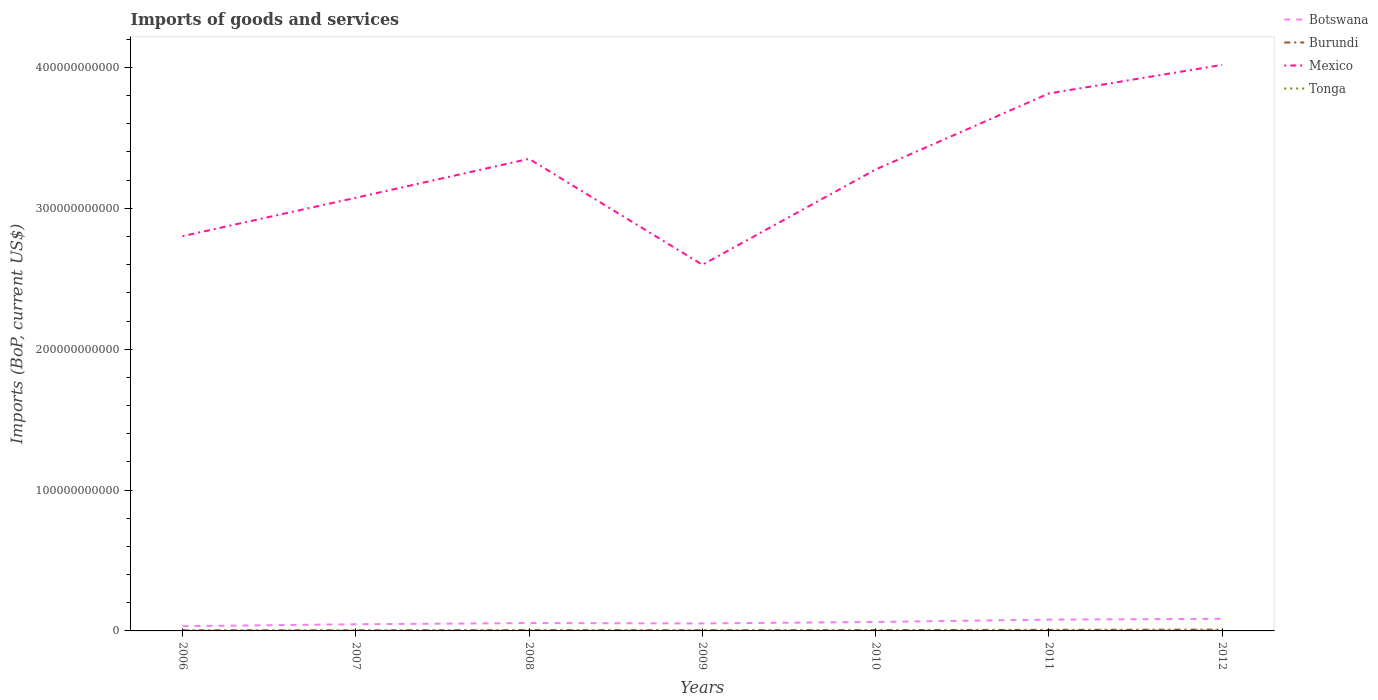Does the line corresponding to Mexico intersect with the line corresponding to Burundi?
Keep it short and to the point. No. Across all years, what is the maximum amount spent on imports in Tonga?
Keep it short and to the point. 1.70e+08. In which year was the amount spent on imports in Botswana maximum?
Your response must be concise. 2006. What is the total amount spent on imports in Botswana in the graph?
Your response must be concise. -1.62e+09. What is the difference between the highest and the second highest amount spent on imports in Burundi?
Provide a short and direct response. 4.86e+08. What is the difference between the highest and the lowest amount spent on imports in Burundi?
Your response must be concise. 2. Is the amount spent on imports in Tonga strictly greater than the amount spent on imports in Burundi over the years?
Ensure brevity in your answer.  Yes. How many years are there in the graph?
Offer a terse response. 7. What is the difference between two consecutive major ticks on the Y-axis?
Your response must be concise. 1.00e+11. Does the graph contain grids?
Keep it short and to the point. No. How are the legend labels stacked?
Make the answer very short. Vertical. What is the title of the graph?
Your answer should be compact. Imports of goods and services. What is the label or title of the X-axis?
Make the answer very short. Years. What is the label or title of the Y-axis?
Offer a terse response. Imports (BoP, current US$). What is the Imports (BoP, current US$) in Botswana in 2006?
Offer a very short reply. 3.35e+09. What is the Imports (BoP, current US$) in Burundi in 2006?
Your response must be concise. 4.47e+08. What is the Imports (BoP, current US$) in Mexico in 2006?
Make the answer very short. 2.80e+11. What is the Imports (BoP, current US$) of Tonga in 2006?
Offer a terse response. 1.70e+08. What is the Imports (BoP, current US$) of Botswana in 2007?
Your answer should be very brief. 4.73e+09. What is the Imports (BoP, current US$) in Burundi in 2007?
Your response must be concise. 4.36e+08. What is the Imports (BoP, current US$) in Mexico in 2007?
Your answer should be compact. 3.08e+11. What is the Imports (BoP, current US$) of Tonga in 2007?
Your response must be concise. 1.99e+08. What is the Imports (BoP, current US$) in Botswana in 2008?
Your response must be concise. 5.59e+09. What is the Imports (BoP, current US$) of Burundi in 2008?
Provide a short and direct response. 5.94e+08. What is the Imports (BoP, current US$) in Mexico in 2008?
Provide a succinct answer. 3.35e+11. What is the Imports (BoP, current US$) in Tonga in 2008?
Provide a short and direct response. 2.47e+08. What is the Imports (BoP, current US$) of Botswana in 2009?
Offer a terse response. 5.33e+09. What is the Imports (BoP, current US$) in Burundi in 2009?
Make the answer very short. 5.20e+08. What is the Imports (BoP, current US$) of Mexico in 2009?
Your answer should be very brief. 2.60e+11. What is the Imports (BoP, current US$) in Tonga in 2009?
Your response must be concise. 2.39e+08. What is the Imports (BoP, current US$) of Botswana in 2010?
Keep it short and to the point. 6.36e+09. What is the Imports (BoP, current US$) in Burundi in 2010?
Ensure brevity in your answer.  6.07e+08. What is the Imports (BoP, current US$) of Mexico in 2010?
Your answer should be compact. 3.28e+11. What is the Imports (BoP, current US$) of Tonga in 2010?
Ensure brevity in your answer.  2.27e+08. What is the Imports (BoP, current US$) in Botswana in 2011?
Ensure brevity in your answer.  8.03e+09. What is the Imports (BoP, current US$) of Burundi in 2011?
Keep it short and to the point. 7.65e+08. What is the Imports (BoP, current US$) of Mexico in 2011?
Keep it short and to the point. 3.82e+11. What is the Imports (BoP, current US$) in Tonga in 2011?
Your answer should be compact. 2.78e+08. What is the Imports (BoP, current US$) in Botswana in 2012?
Give a very brief answer. 8.59e+09. What is the Imports (BoP, current US$) in Burundi in 2012?
Your response must be concise. 9.23e+08. What is the Imports (BoP, current US$) of Mexico in 2012?
Offer a terse response. 4.02e+11. What is the Imports (BoP, current US$) in Tonga in 2012?
Give a very brief answer. 2.71e+08. Across all years, what is the maximum Imports (BoP, current US$) in Botswana?
Ensure brevity in your answer.  8.59e+09. Across all years, what is the maximum Imports (BoP, current US$) in Burundi?
Offer a very short reply. 9.23e+08. Across all years, what is the maximum Imports (BoP, current US$) in Mexico?
Your answer should be compact. 4.02e+11. Across all years, what is the maximum Imports (BoP, current US$) of Tonga?
Keep it short and to the point. 2.78e+08. Across all years, what is the minimum Imports (BoP, current US$) in Botswana?
Offer a very short reply. 3.35e+09. Across all years, what is the minimum Imports (BoP, current US$) of Burundi?
Ensure brevity in your answer.  4.36e+08. Across all years, what is the minimum Imports (BoP, current US$) of Mexico?
Offer a terse response. 2.60e+11. Across all years, what is the minimum Imports (BoP, current US$) of Tonga?
Make the answer very short. 1.70e+08. What is the total Imports (BoP, current US$) of Botswana in the graph?
Make the answer very short. 4.20e+1. What is the total Imports (BoP, current US$) of Burundi in the graph?
Offer a terse response. 4.29e+09. What is the total Imports (BoP, current US$) of Mexico in the graph?
Ensure brevity in your answer.  2.29e+12. What is the total Imports (BoP, current US$) in Tonga in the graph?
Provide a short and direct response. 1.63e+09. What is the difference between the Imports (BoP, current US$) of Botswana in 2006 and that in 2007?
Offer a very short reply. -1.38e+09. What is the difference between the Imports (BoP, current US$) in Burundi in 2006 and that in 2007?
Your answer should be compact. 1.07e+07. What is the difference between the Imports (BoP, current US$) of Mexico in 2006 and that in 2007?
Provide a succinct answer. -2.72e+1. What is the difference between the Imports (BoP, current US$) of Tonga in 2006 and that in 2007?
Provide a succinct answer. -2.89e+07. What is the difference between the Imports (BoP, current US$) in Botswana in 2006 and that in 2008?
Your response must be concise. -2.23e+09. What is the difference between the Imports (BoP, current US$) of Burundi in 2006 and that in 2008?
Offer a terse response. -1.47e+08. What is the difference between the Imports (BoP, current US$) of Mexico in 2006 and that in 2008?
Provide a short and direct response. -5.49e+1. What is the difference between the Imports (BoP, current US$) of Tonga in 2006 and that in 2008?
Provide a succinct answer. -7.70e+07. What is the difference between the Imports (BoP, current US$) in Botswana in 2006 and that in 2009?
Keep it short and to the point. -1.97e+09. What is the difference between the Imports (BoP, current US$) in Burundi in 2006 and that in 2009?
Give a very brief answer. -7.27e+07. What is the difference between the Imports (BoP, current US$) of Mexico in 2006 and that in 2009?
Your response must be concise. 2.03e+1. What is the difference between the Imports (BoP, current US$) in Tonga in 2006 and that in 2009?
Ensure brevity in your answer.  -6.88e+07. What is the difference between the Imports (BoP, current US$) of Botswana in 2006 and that in 2010?
Make the answer very short. -3.01e+09. What is the difference between the Imports (BoP, current US$) in Burundi in 2006 and that in 2010?
Your response must be concise. -1.60e+08. What is the difference between the Imports (BoP, current US$) in Mexico in 2006 and that in 2010?
Your answer should be compact. -4.73e+1. What is the difference between the Imports (BoP, current US$) of Tonga in 2006 and that in 2010?
Make the answer very short. -5.69e+07. What is the difference between the Imports (BoP, current US$) of Botswana in 2006 and that in 2011?
Offer a very short reply. -4.68e+09. What is the difference between the Imports (BoP, current US$) of Burundi in 2006 and that in 2011?
Ensure brevity in your answer.  -3.18e+08. What is the difference between the Imports (BoP, current US$) in Mexico in 2006 and that in 2011?
Give a very brief answer. -1.01e+11. What is the difference between the Imports (BoP, current US$) in Tonga in 2006 and that in 2011?
Ensure brevity in your answer.  -1.07e+08. What is the difference between the Imports (BoP, current US$) in Botswana in 2006 and that in 2012?
Your answer should be very brief. -5.24e+09. What is the difference between the Imports (BoP, current US$) of Burundi in 2006 and that in 2012?
Make the answer very short. -4.76e+08. What is the difference between the Imports (BoP, current US$) of Mexico in 2006 and that in 2012?
Your answer should be compact. -1.22e+11. What is the difference between the Imports (BoP, current US$) in Tonga in 2006 and that in 2012?
Offer a very short reply. -1.00e+08. What is the difference between the Imports (BoP, current US$) of Botswana in 2007 and that in 2008?
Offer a very short reply. -8.52e+08. What is the difference between the Imports (BoP, current US$) in Burundi in 2007 and that in 2008?
Make the answer very short. -1.58e+08. What is the difference between the Imports (BoP, current US$) of Mexico in 2007 and that in 2008?
Your answer should be very brief. -2.76e+1. What is the difference between the Imports (BoP, current US$) in Tonga in 2007 and that in 2008?
Provide a short and direct response. -4.81e+07. What is the difference between the Imports (BoP, current US$) in Botswana in 2007 and that in 2009?
Your response must be concise. -5.93e+08. What is the difference between the Imports (BoP, current US$) of Burundi in 2007 and that in 2009?
Your answer should be very brief. -8.34e+07. What is the difference between the Imports (BoP, current US$) of Mexico in 2007 and that in 2009?
Keep it short and to the point. 4.76e+1. What is the difference between the Imports (BoP, current US$) in Tonga in 2007 and that in 2009?
Provide a short and direct response. -3.99e+07. What is the difference between the Imports (BoP, current US$) of Botswana in 2007 and that in 2010?
Offer a very short reply. -1.62e+09. What is the difference between the Imports (BoP, current US$) of Burundi in 2007 and that in 2010?
Your answer should be very brief. -1.70e+08. What is the difference between the Imports (BoP, current US$) in Mexico in 2007 and that in 2010?
Give a very brief answer. -2.01e+1. What is the difference between the Imports (BoP, current US$) of Tonga in 2007 and that in 2010?
Your answer should be compact. -2.79e+07. What is the difference between the Imports (BoP, current US$) in Botswana in 2007 and that in 2011?
Your response must be concise. -3.30e+09. What is the difference between the Imports (BoP, current US$) of Burundi in 2007 and that in 2011?
Your answer should be compact. -3.29e+08. What is the difference between the Imports (BoP, current US$) of Mexico in 2007 and that in 2011?
Provide a short and direct response. -7.41e+1. What is the difference between the Imports (BoP, current US$) in Tonga in 2007 and that in 2011?
Provide a short and direct response. -7.82e+07. What is the difference between the Imports (BoP, current US$) in Botswana in 2007 and that in 2012?
Offer a terse response. -3.85e+09. What is the difference between the Imports (BoP, current US$) of Burundi in 2007 and that in 2012?
Your answer should be compact. -4.86e+08. What is the difference between the Imports (BoP, current US$) in Mexico in 2007 and that in 2012?
Offer a very short reply. -9.44e+1. What is the difference between the Imports (BoP, current US$) in Tonga in 2007 and that in 2012?
Provide a short and direct response. -7.12e+07. What is the difference between the Imports (BoP, current US$) in Botswana in 2008 and that in 2009?
Provide a succinct answer. 2.60e+08. What is the difference between the Imports (BoP, current US$) of Burundi in 2008 and that in 2009?
Ensure brevity in your answer.  7.46e+07. What is the difference between the Imports (BoP, current US$) of Mexico in 2008 and that in 2009?
Your answer should be compact. 7.52e+1. What is the difference between the Imports (BoP, current US$) of Tonga in 2008 and that in 2009?
Give a very brief answer. 8.26e+06. What is the difference between the Imports (BoP, current US$) in Botswana in 2008 and that in 2010?
Make the answer very short. -7.70e+08. What is the difference between the Imports (BoP, current US$) of Burundi in 2008 and that in 2010?
Your answer should be compact. -1.25e+07. What is the difference between the Imports (BoP, current US$) in Mexico in 2008 and that in 2010?
Offer a very short reply. 7.56e+09. What is the difference between the Imports (BoP, current US$) in Tonga in 2008 and that in 2010?
Give a very brief answer. 2.02e+07. What is the difference between the Imports (BoP, current US$) in Botswana in 2008 and that in 2011?
Provide a succinct answer. -2.44e+09. What is the difference between the Imports (BoP, current US$) in Burundi in 2008 and that in 2011?
Offer a very short reply. -1.71e+08. What is the difference between the Imports (BoP, current US$) in Mexico in 2008 and that in 2011?
Give a very brief answer. -4.64e+1. What is the difference between the Imports (BoP, current US$) in Tonga in 2008 and that in 2011?
Offer a very short reply. -3.01e+07. What is the difference between the Imports (BoP, current US$) of Botswana in 2008 and that in 2012?
Keep it short and to the point. -3.00e+09. What is the difference between the Imports (BoP, current US$) of Burundi in 2008 and that in 2012?
Provide a succinct answer. -3.28e+08. What is the difference between the Imports (BoP, current US$) of Mexico in 2008 and that in 2012?
Give a very brief answer. -6.67e+1. What is the difference between the Imports (BoP, current US$) of Tonga in 2008 and that in 2012?
Your answer should be very brief. -2.31e+07. What is the difference between the Imports (BoP, current US$) of Botswana in 2009 and that in 2010?
Offer a very short reply. -1.03e+09. What is the difference between the Imports (BoP, current US$) in Burundi in 2009 and that in 2010?
Provide a succinct answer. -8.71e+07. What is the difference between the Imports (BoP, current US$) in Mexico in 2009 and that in 2010?
Your answer should be very brief. -6.77e+1. What is the difference between the Imports (BoP, current US$) in Tonga in 2009 and that in 2010?
Your response must be concise. 1.19e+07. What is the difference between the Imports (BoP, current US$) of Botswana in 2009 and that in 2011?
Give a very brief answer. -2.70e+09. What is the difference between the Imports (BoP, current US$) in Burundi in 2009 and that in 2011?
Provide a succinct answer. -2.46e+08. What is the difference between the Imports (BoP, current US$) of Mexico in 2009 and that in 2011?
Offer a very short reply. -1.22e+11. What is the difference between the Imports (BoP, current US$) of Tonga in 2009 and that in 2011?
Your answer should be compact. -3.84e+07. What is the difference between the Imports (BoP, current US$) of Botswana in 2009 and that in 2012?
Your response must be concise. -3.26e+09. What is the difference between the Imports (BoP, current US$) in Burundi in 2009 and that in 2012?
Your answer should be compact. -4.03e+08. What is the difference between the Imports (BoP, current US$) in Mexico in 2009 and that in 2012?
Your response must be concise. -1.42e+11. What is the difference between the Imports (BoP, current US$) in Tonga in 2009 and that in 2012?
Your answer should be compact. -3.14e+07. What is the difference between the Imports (BoP, current US$) of Botswana in 2010 and that in 2011?
Provide a succinct answer. -1.67e+09. What is the difference between the Imports (BoP, current US$) in Burundi in 2010 and that in 2011?
Your answer should be compact. -1.59e+08. What is the difference between the Imports (BoP, current US$) in Mexico in 2010 and that in 2011?
Your answer should be very brief. -5.40e+1. What is the difference between the Imports (BoP, current US$) of Tonga in 2010 and that in 2011?
Offer a very short reply. -5.03e+07. What is the difference between the Imports (BoP, current US$) in Botswana in 2010 and that in 2012?
Offer a terse response. -2.23e+09. What is the difference between the Imports (BoP, current US$) of Burundi in 2010 and that in 2012?
Your answer should be very brief. -3.16e+08. What is the difference between the Imports (BoP, current US$) in Mexico in 2010 and that in 2012?
Your answer should be very brief. -7.43e+1. What is the difference between the Imports (BoP, current US$) in Tonga in 2010 and that in 2012?
Make the answer very short. -4.33e+07. What is the difference between the Imports (BoP, current US$) in Botswana in 2011 and that in 2012?
Provide a short and direct response. -5.57e+08. What is the difference between the Imports (BoP, current US$) of Burundi in 2011 and that in 2012?
Make the answer very short. -1.57e+08. What is the difference between the Imports (BoP, current US$) in Mexico in 2011 and that in 2012?
Your answer should be very brief. -2.03e+1. What is the difference between the Imports (BoP, current US$) of Tonga in 2011 and that in 2012?
Offer a terse response. 7.00e+06. What is the difference between the Imports (BoP, current US$) in Botswana in 2006 and the Imports (BoP, current US$) in Burundi in 2007?
Provide a succinct answer. 2.92e+09. What is the difference between the Imports (BoP, current US$) in Botswana in 2006 and the Imports (BoP, current US$) in Mexico in 2007?
Ensure brevity in your answer.  -3.04e+11. What is the difference between the Imports (BoP, current US$) of Botswana in 2006 and the Imports (BoP, current US$) of Tonga in 2007?
Give a very brief answer. 3.15e+09. What is the difference between the Imports (BoP, current US$) in Burundi in 2006 and the Imports (BoP, current US$) in Mexico in 2007?
Give a very brief answer. -3.07e+11. What is the difference between the Imports (BoP, current US$) in Burundi in 2006 and the Imports (BoP, current US$) in Tonga in 2007?
Provide a succinct answer. 2.48e+08. What is the difference between the Imports (BoP, current US$) in Mexico in 2006 and the Imports (BoP, current US$) in Tonga in 2007?
Give a very brief answer. 2.80e+11. What is the difference between the Imports (BoP, current US$) of Botswana in 2006 and the Imports (BoP, current US$) of Burundi in 2008?
Provide a succinct answer. 2.76e+09. What is the difference between the Imports (BoP, current US$) of Botswana in 2006 and the Imports (BoP, current US$) of Mexico in 2008?
Provide a short and direct response. -3.32e+11. What is the difference between the Imports (BoP, current US$) in Botswana in 2006 and the Imports (BoP, current US$) in Tonga in 2008?
Your answer should be very brief. 3.10e+09. What is the difference between the Imports (BoP, current US$) in Burundi in 2006 and the Imports (BoP, current US$) in Mexico in 2008?
Make the answer very short. -3.35e+11. What is the difference between the Imports (BoP, current US$) in Burundi in 2006 and the Imports (BoP, current US$) in Tonga in 2008?
Make the answer very short. 1.99e+08. What is the difference between the Imports (BoP, current US$) of Mexico in 2006 and the Imports (BoP, current US$) of Tonga in 2008?
Your answer should be very brief. 2.80e+11. What is the difference between the Imports (BoP, current US$) of Botswana in 2006 and the Imports (BoP, current US$) of Burundi in 2009?
Make the answer very short. 2.83e+09. What is the difference between the Imports (BoP, current US$) in Botswana in 2006 and the Imports (BoP, current US$) in Mexico in 2009?
Your response must be concise. -2.57e+11. What is the difference between the Imports (BoP, current US$) of Botswana in 2006 and the Imports (BoP, current US$) of Tonga in 2009?
Keep it short and to the point. 3.11e+09. What is the difference between the Imports (BoP, current US$) in Burundi in 2006 and the Imports (BoP, current US$) in Mexico in 2009?
Provide a short and direct response. -2.59e+11. What is the difference between the Imports (BoP, current US$) in Burundi in 2006 and the Imports (BoP, current US$) in Tonga in 2009?
Your answer should be compact. 2.08e+08. What is the difference between the Imports (BoP, current US$) of Mexico in 2006 and the Imports (BoP, current US$) of Tonga in 2009?
Offer a very short reply. 2.80e+11. What is the difference between the Imports (BoP, current US$) of Botswana in 2006 and the Imports (BoP, current US$) of Burundi in 2010?
Provide a succinct answer. 2.75e+09. What is the difference between the Imports (BoP, current US$) in Botswana in 2006 and the Imports (BoP, current US$) in Mexico in 2010?
Make the answer very short. -3.24e+11. What is the difference between the Imports (BoP, current US$) of Botswana in 2006 and the Imports (BoP, current US$) of Tonga in 2010?
Your answer should be very brief. 3.12e+09. What is the difference between the Imports (BoP, current US$) in Burundi in 2006 and the Imports (BoP, current US$) in Mexico in 2010?
Ensure brevity in your answer.  -3.27e+11. What is the difference between the Imports (BoP, current US$) of Burundi in 2006 and the Imports (BoP, current US$) of Tonga in 2010?
Make the answer very short. 2.20e+08. What is the difference between the Imports (BoP, current US$) of Mexico in 2006 and the Imports (BoP, current US$) of Tonga in 2010?
Offer a very short reply. 2.80e+11. What is the difference between the Imports (BoP, current US$) in Botswana in 2006 and the Imports (BoP, current US$) in Burundi in 2011?
Make the answer very short. 2.59e+09. What is the difference between the Imports (BoP, current US$) in Botswana in 2006 and the Imports (BoP, current US$) in Mexico in 2011?
Your response must be concise. -3.78e+11. What is the difference between the Imports (BoP, current US$) of Botswana in 2006 and the Imports (BoP, current US$) of Tonga in 2011?
Your answer should be very brief. 3.07e+09. What is the difference between the Imports (BoP, current US$) of Burundi in 2006 and the Imports (BoP, current US$) of Mexico in 2011?
Make the answer very short. -3.81e+11. What is the difference between the Imports (BoP, current US$) of Burundi in 2006 and the Imports (BoP, current US$) of Tonga in 2011?
Provide a short and direct response. 1.69e+08. What is the difference between the Imports (BoP, current US$) of Mexico in 2006 and the Imports (BoP, current US$) of Tonga in 2011?
Ensure brevity in your answer.  2.80e+11. What is the difference between the Imports (BoP, current US$) of Botswana in 2006 and the Imports (BoP, current US$) of Burundi in 2012?
Offer a terse response. 2.43e+09. What is the difference between the Imports (BoP, current US$) of Botswana in 2006 and the Imports (BoP, current US$) of Mexico in 2012?
Provide a succinct answer. -3.99e+11. What is the difference between the Imports (BoP, current US$) of Botswana in 2006 and the Imports (BoP, current US$) of Tonga in 2012?
Give a very brief answer. 3.08e+09. What is the difference between the Imports (BoP, current US$) of Burundi in 2006 and the Imports (BoP, current US$) of Mexico in 2012?
Provide a succinct answer. -4.01e+11. What is the difference between the Imports (BoP, current US$) of Burundi in 2006 and the Imports (BoP, current US$) of Tonga in 2012?
Your answer should be very brief. 1.76e+08. What is the difference between the Imports (BoP, current US$) in Mexico in 2006 and the Imports (BoP, current US$) in Tonga in 2012?
Offer a terse response. 2.80e+11. What is the difference between the Imports (BoP, current US$) of Botswana in 2007 and the Imports (BoP, current US$) of Burundi in 2008?
Offer a terse response. 4.14e+09. What is the difference between the Imports (BoP, current US$) of Botswana in 2007 and the Imports (BoP, current US$) of Mexico in 2008?
Offer a terse response. -3.30e+11. What is the difference between the Imports (BoP, current US$) in Botswana in 2007 and the Imports (BoP, current US$) in Tonga in 2008?
Provide a short and direct response. 4.49e+09. What is the difference between the Imports (BoP, current US$) of Burundi in 2007 and the Imports (BoP, current US$) of Mexico in 2008?
Offer a terse response. -3.35e+11. What is the difference between the Imports (BoP, current US$) in Burundi in 2007 and the Imports (BoP, current US$) in Tonga in 2008?
Offer a very short reply. 1.89e+08. What is the difference between the Imports (BoP, current US$) in Mexico in 2007 and the Imports (BoP, current US$) in Tonga in 2008?
Ensure brevity in your answer.  3.07e+11. What is the difference between the Imports (BoP, current US$) of Botswana in 2007 and the Imports (BoP, current US$) of Burundi in 2009?
Ensure brevity in your answer.  4.21e+09. What is the difference between the Imports (BoP, current US$) in Botswana in 2007 and the Imports (BoP, current US$) in Mexico in 2009?
Offer a very short reply. -2.55e+11. What is the difference between the Imports (BoP, current US$) of Botswana in 2007 and the Imports (BoP, current US$) of Tonga in 2009?
Provide a short and direct response. 4.50e+09. What is the difference between the Imports (BoP, current US$) in Burundi in 2007 and the Imports (BoP, current US$) in Mexico in 2009?
Ensure brevity in your answer.  -2.60e+11. What is the difference between the Imports (BoP, current US$) of Burundi in 2007 and the Imports (BoP, current US$) of Tonga in 2009?
Provide a succinct answer. 1.97e+08. What is the difference between the Imports (BoP, current US$) of Mexico in 2007 and the Imports (BoP, current US$) of Tonga in 2009?
Keep it short and to the point. 3.07e+11. What is the difference between the Imports (BoP, current US$) of Botswana in 2007 and the Imports (BoP, current US$) of Burundi in 2010?
Offer a terse response. 4.13e+09. What is the difference between the Imports (BoP, current US$) in Botswana in 2007 and the Imports (BoP, current US$) in Mexico in 2010?
Your response must be concise. -3.23e+11. What is the difference between the Imports (BoP, current US$) in Botswana in 2007 and the Imports (BoP, current US$) in Tonga in 2010?
Ensure brevity in your answer.  4.51e+09. What is the difference between the Imports (BoP, current US$) of Burundi in 2007 and the Imports (BoP, current US$) of Mexico in 2010?
Your answer should be compact. -3.27e+11. What is the difference between the Imports (BoP, current US$) of Burundi in 2007 and the Imports (BoP, current US$) of Tonga in 2010?
Give a very brief answer. 2.09e+08. What is the difference between the Imports (BoP, current US$) in Mexico in 2007 and the Imports (BoP, current US$) in Tonga in 2010?
Offer a terse response. 3.07e+11. What is the difference between the Imports (BoP, current US$) in Botswana in 2007 and the Imports (BoP, current US$) in Burundi in 2011?
Provide a succinct answer. 3.97e+09. What is the difference between the Imports (BoP, current US$) of Botswana in 2007 and the Imports (BoP, current US$) of Mexico in 2011?
Your response must be concise. -3.77e+11. What is the difference between the Imports (BoP, current US$) in Botswana in 2007 and the Imports (BoP, current US$) in Tonga in 2011?
Your answer should be compact. 4.46e+09. What is the difference between the Imports (BoP, current US$) of Burundi in 2007 and the Imports (BoP, current US$) of Mexico in 2011?
Your response must be concise. -3.81e+11. What is the difference between the Imports (BoP, current US$) in Burundi in 2007 and the Imports (BoP, current US$) in Tonga in 2011?
Keep it short and to the point. 1.59e+08. What is the difference between the Imports (BoP, current US$) in Mexico in 2007 and the Imports (BoP, current US$) in Tonga in 2011?
Give a very brief answer. 3.07e+11. What is the difference between the Imports (BoP, current US$) of Botswana in 2007 and the Imports (BoP, current US$) of Burundi in 2012?
Make the answer very short. 3.81e+09. What is the difference between the Imports (BoP, current US$) of Botswana in 2007 and the Imports (BoP, current US$) of Mexico in 2012?
Keep it short and to the point. -3.97e+11. What is the difference between the Imports (BoP, current US$) in Botswana in 2007 and the Imports (BoP, current US$) in Tonga in 2012?
Provide a succinct answer. 4.46e+09. What is the difference between the Imports (BoP, current US$) of Burundi in 2007 and the Imports (BoP, current US$) of Mexico in 2012?
Ensure brevity in your answer.  -4.01e+11. What is the difference between the Imports (BoP, current US$) in Burundi in 2007 and the Imports (BoP, current US$) in Tonga in 2012?
Offer a very short reply. 1.66e+08. What is the difference between the Imports (BoP, current US$) of Mexico in 2007 and the Imports (BoP, current US$) of Tonga in 2012?
Ensure brevity in your answer.  3.07e+11. What is the difference between the Imports (BoP, current US$) in Botswana in 2008 and the Imports (BoP, current US$) in Burundi in 2009?
Your response must be concise. 5.07e+09. What is the difference between the Imports (BoP, current US$) of Botswana in 2008 and the Imports (BoP, current US$) of Mexico in 2009?
Give a very brief answer. -2.54e+11. What is the difference between the Imports (BoP, current US$) of Botswana in 2008 and the Imports (BoP, current US$) of Tonga in 2009?
Offer a very short reply. 5.35e+09. What is the difference between the Imports (BoP, current US$) in Burundi in 2008 and the Imports (BoP, current US$) in Mexico in 2009?
Make the answer very short. -2.59e+11. What is the difference between the Imports (BoP, current US$) in Burundi in 2008 and the Imports (BoP, current US$) in Tonga in 2009?
Offer a terse response. 3.55e+08. What is the difference between the Imports (BoP, current US$) of Mexico in 2008 and the Imports (BoP, current US$) of Tonga in 2009?
Offer a very short reply. 3.35e+11. What is the difference between the Imports (BoP, current US$) of Botswana in 2008 and the Imports (BoP, current US$) of Burundi in 2010?
Your response must be concise. 4.98e+09. What is the difference between the Imports (BoP, current US$) in Botswana in 2008 and the Imports (BoP, current US$) in Mexico in 2010?
Keep it short and to the point. -3.22e+11. What is the difference between the Imports (BoP, current US$) of Botswana in 2008 and the Imports (BoP, current US$) of Tonga in 2010?
Give a very brief answer. 5.36e+09. What is the difference between the Imports (BoP, current US$) of Burundi in 2008 and the Imports (BoP, current US$) of Mexico in 2010?
Provide a short and direct response. -3.27e+11. What is the difference between the Imports (BoP, current US$) in Burundi in 2008 and the Imports (BoP, current US$) in Tonga in 2010?
Provide a short and direct response. 3.67e+08. What is the difference between the Imports (BoP, current US$) of Mexico in 2008 and the Imports (BoP, current US$) of Tonga in 2010?
Provide a short and direct response. 3.35e+11. What is the difference between the Imports (BoP, current US$) of Botswana in 2008 and the Imports (BoP, current US$) of Burundi in 2011?
Provide a succinct answer. 4.82e+09. What is the difference between the Imports (BoP, current US$) of Botswana in 2008 and the Imports (BoP, current US$) of Mexico in 2011?
Keep it short and to the point. -3.76e+11. What is the difference between the Imports (BoP, current US$) of Botswana in 2008 and the Imports (BoP, current US$) of Tonga in 2011?
Make the answer very short. 5.31e+09. What is the difference between the Imports (BoP, current US$) of Burundi in 2008 and the Imports (BoP, current US$) of Mexico in 2011?
Your answer should be compact. -3.81e+11. What is the difference between the Imports (BoP, current US$) in Burundi in 2008 and the Imports (BoP, current US$) in Tonga in 2011?
Give a very brief answer. 3.17e+08. What is the difference between the Imports (BoP, current US$) in Mexico in 2008 and the Imports (BoP, current US$) in Tonga in 2011?
Your answer should be very brief. 3.35e+11. What is the difference between the Imports (BoP, current US$) in Botswana in 2008 and the Imports (BoP, current US$) in Burundi in 2012?
Provide a succinct answer. 4.66e+09. What is the difference between the Imports (BoP, current US$) of Botswana in 2008 and the Imports (BoP, current US$) of Mexico in 2012?
Your response must be concise. -3.96e+11. What is the difference between the Imports (BoP, current US$) of Botswana in 2008 and the Imports (BoP, current US$) of Tonga in 2012?
Provide a succinct answer. 5.32e+09. What is the difference between the Imports (BoP, current US$) of Burundi in 2008 and the Imports (BoP, current US$) of Mexico in 2012?
Your answer should be compact. -4.01e+11. What is the difference between the Imports (BoP, current US$) of Burundi in 2008 and the Imports (BoP, current US$) of Tonga in 2012?
Provide a succinct answer. 3.24e+08. What is the difference between the Imports (BoP, current US$) of Mexico in 2008 and the Imports (BoP, current US$) of Tonga in 2012?
Make the answer very short. 3.35e+11. What is the difference between the Imports (BoP, current US$) of Botswana in 2009 and the Imports (BoP, current US$) of Burundi in 2010?
Make the answer very short. 4.72e+09. What is the difference between the Imports (BoP, current US$) in Botswana in 2009 and the Imports (BoP, current US$) in Mexico in 2010?
Your answer should be very brief. -3.22e+11. What is the difference between the Imports (BoP, current US$) of Botswana in 2009 and the Imports (BoP, current US$) of Tonga in 2010?
Give a very brief answer. 5.10e+09. What is the difference between the Imports (BoP, current US$) of Burundi in 2009 and the Imports (BoP, current US$) of Mexico in 2010?
Provide a short and direct response. -3.27e+11. What is the difference between the Imports (BoP, current US$) in Burundi in 2009 and the Imports (BoP, current US$) in Tonga in 2010?
Make the answer very short. 2.92e+08. What is the difference between the Imports (BoP, current US$) in Mexico in 2009 and the Imports (BoP, current US$) in Tonga in 2010?
Provide a succinct answer. 2.60e+11. What is the difference between the Imports (BoP, current US$) of Botswana in 2009 and the Imports (BoP, current US$) of Burundi in 2011?
Your answer should be compact. 4.56e+09. What is the difference between the Imports (BoP, current US$) in Botswana in 2009 and the Imports (BoP, current US$) in Mexico in 2011?
Keep it short and to the point. -3.76e+11. What is the difference between the Imports (BoP, current US$) in Botswana in 2009 and the Imports (BoP, current US$) in Tonga in 2011?
Your answer should be very brief. 5.05e+09. What is the difference between the Imports (BoP, current US$) in Burundi in 2009 and the Imports (BoP, current US$) in Mexico in 2011?
Provide a succinct answer. -3.81e+11. What is the difference between the Imports (BoP, current US$) of Burundi in 2009 and the Imports (BoP, current US$) of Tonga in 2011?
Offer a very short reply. 2.42e+08. What is the difference between the Imports (BoP, current US$) in Mexico in 2009 and the Imports (BoP, current US$) in Tonga in 2011?
Offer a terse response. 2.60e+11. What is the difference between the Imports (BoP, current US$) of Botswana in 2009 and the Imports (BoP, current US$) of Burundi in 2012?
Your answer should be compact. 4.40e+09. What is the difference between the Imports (BoP, current US$) in Botswana in 2009 and the Imports (BoP, current US$) in Mexico in 2012?
Your answer should be very brief. -3.97e+11. What is the difference between the Imports (BoP, current US$) in Botswana in 2009 and the Imports (BoP, current US$) in Tonga in 2012?
Ensure brevity in your answer.  5.06e+09. What is the difference between the Imports (BoP, current US$) in Burundi in 2009 and the Imports (BoP, current US$) in Mexico in 2012?
Provide a succinct answer. -4.01e+11. What is the difference between the Imports (BoP, current US$) of Burundi in 2009 and the Imports (BoP, current US$) of Tonga in 2012?
Provide a succinct answer. 2.49e+08. What is the difference between the Imports (BoP, current US$) in Mexico in 2009 and the Imports (BoP, current US$) in Tonga in 2012?
Your answer should be compact. 2.60e+11. What is the difference between the Imports (BoP, current US$) of Botswana in 2010 and the Imports (BoP, current US$) of Burundi in 2011?
Provide a short and direct response. 5.59e+09. What is the difference between the Imports (BoP, current US$) in Botswana in 2010 and the Imports (BoP, current US$) in Mexico in 2011?
Offer a terse response. -3.75e+11. What is the difference between the Imports (BoP, current US$) of Botswana in 2010 and the Imports (BoP, current US$) of Tonga in 2011?
Your response must be concise. 6.08e+09. What is the difference between the Imports (BoP, current US$) in Burundi in 2010 and the Imports (BoP, current US$) in Mexico in 2011?
Offer a terse response. -3.81e+11. What is the difference between the Imports (BoP, current US$) in Burundi in 2010 and the Imports (BoP, current US$) in Tonga in 2011?
Make the answer very short. 3.29e+08. What is the difference between the Imports (BoP, current US$) in Mexico in 2010 and the Imports (BoP, current US$) in Tonga in 2011?
Make the answer very short. 3.27e+11. What is the difference between the Imports (BoP, current US$) of Botswana in 2010 and the Imports (BoP, current US$) of Burundi in 2012?
Offer a terse response. 5.43e+09. What is the difference between the Imports (BoP, current US$) of Botswana in 2010 and the Imports (BoP, current US$) of Mexico in 2012?
Ensure brevity in your answer.  -3.96e+11. What is the difference between the Imports (BoP, current US$) in Botswana in 2010 and the Imports (BoP, current US$) in Tonga in 2012?
Your answer should be very brief. 6.09e+09. What is the difference between the Imports (BoP, current US$) of Burundi in 2010 and the Imports (BoP, current US$) of Mexico in 2012?
Keep it short and to the point. -4.01e+11. What is the difference between the Imports (BoP, current US$) in Burundi in 2010 and the Imports (BoP, current US$) in Tonga in 2012?
Your answer should be very brief. 3.36e+08. What is the difference between the Imports (BoP, current US$) in Mexico in 2010 and the Imports (BoP, current US$) in Tonga in 2012?
Provide a short and direct response. 3.27e+11. What is the difference between the Imports (BoP, current US$) of Botswana in 2011 and the Imports (BoP, current US$) of Burundi in 2012?
Provide a succinct answer. 7.11e+09. What is the difference between the Imports (BoP, current US$) in Botswana in 2011 and the Imports (BoP, current US$) in Mexico in 2012?
Keep it short and to the point. -3.94e+11. What is the difference between the Imports (BoP, current US$) in Botswana in 2011 and the Imports (BoP, current US$) in Tonga in 2012?
Offer a very short reply. 7.76e+09. What is the difference between the Imports (BoP, current US$) of Burundi in 2011 and the Imports (BoP, current US$) of Mexico in 2012?
Provide a short and direct response. -4.01e+11. What is the difference between the Imports (BoP, current US$) of Burundi in 2011 and the Imports (BoP, current US$) of Tonga in 2012?
Your answer should be very brief. 4.95e+08. What is the difference between the Imports (BoP, current US$) of Mexico in 2011 and the Imports (BoP, current US$) of Tonga in 2012?
Provide a short and direct response. 3.81e+11. What is the average Imports (BoP, current US$) of Botswana per year?
Ensure brevity in your answer.  6.00e+09. What is the average Imports (BoP, current US$) in Burundi per year?
Give a very brief answer. 6.13e+08. What is the average Imports (BoP, current US$) of Mexico per year?
Your answer should be very brief. 3.28e+11. What is the average Imports (BoP, current US$) in Tonga per year?
Your answer should be compact. 2.33e+08. In the year 2006, what is the difference between the Imports (BoP, current US$) in Botswana and Imports (BoP, current US$) in Burundi?
Make the answer very short. 2.91e+09. In the year 2006, what is the difference between the Imports (BoP, current US$) in Botswana and Imports (BoP, current US$) in Mexico?
Offer a terse response. -2.77e+11. In the year 2006, what is the difference between the Imports (BoP, current US$) in Botswana and Imports (BoP, current US$) in Tonga?
Your answer should be very brief. 3.18e+09. In the year 2006, what is the difference between the Imports (BoP, current US$) of Burundi and Imports (BoP, current US$) of Mexico?
Keep it short and to the point. -2.80e+11. In the year 2006, what is the difference between the Imports (BoP, current US$) of Burundi and Imports (BoP, current US$) of Tonga?
Provide a short and direct response. 2.76e+08. In the year 2006, what is the difference between the Imports (BoP, current US$) in Mexico and Imports (BoP, current US$) in Tonga?
Give a very brief answer. 2.80e+11. In the year 2007, what is the difference between the Imports (BoP, current US$) of Botswana and Imports (BoP, current US$) of Burundi?
Your answer should be compact. 4.30e+09. In the year 2007, what is the difference between the Imports (BoP, current US$) in Botswana and Imports (BoP, current US$) in Mexico?
Your answer should be very brief. -3.03e+11. In the year 2007, what is the difference between the Imports (BoP, current US$) of Botswana and Imports (BoP, current US$) of Tonga?
Give a very brief answer. 4.54e+09. In the year 2007, what is the difference between the Imports (BoP, current US$) in Burundi and Imports (BoP, current US$) in Mexico?
Give a very brief answer. -3.07e+11. In the year 2007, what is the difference between the Imports (BoP, current US$) in Burundi and Imports (BoP, current US$) in Tonga?
Offer a very short reply. 2.37e+08. In the year 2007, what is the difference between the Imports (BoP, current US$) in Mexico and Imports (BoP, current US$) in Tonga?
Provide a succinct answer. 3.07e+11. In the year 2008, what is the difference between the Imports (BoP, current US$) of Botswana and Imports (BoP, current US$) of Burundi?
Your answer should be compact. 4.99e+09. In the year 2008, what is the difference between the Imports (BoP, current US$) of Botswana and Imports (BoP, current US$) of Mexico?
Offer a terse response. -3.30e+11. In the year 2008, what is the difference between the Imports (BoP, current US$) of Botswana and Imports (BoP, current US$) of Tonga?
Offer a very short reply. 5.34e+09. In the year 2008, what is the difference between the Imports (BoP, current US$) of Burundi and Imports (BoP, current US$) of Mexico?
Your answer should be compact. -3.35e+11. In the year 2008, what is the difference between the Imports (BoP, current US$) in Burundi and Imports (BoP, current US$) in Tonga?
Give a very brief answer. 3.47e+08. In the year 2008, what is the difference between the Imports (BoP, current US$) in Mexico and Imports (BoP, current US$) in Tonga?
Give a very brief answer. 3.35e+11. In the year 2009, what is the difference between the Imports (BoP, current US$) in Botswana and Imports (BoP, current US$) in Burundi?
Your answer should be compact. 4.81e+09. In the year 2009, what is the difference between the Imports (BoP, current US$) in Botswana and Imports (BoP, current US$) in Mexico?
Offer a terse response. -2.55e+11. In the year 2009, what is the difference between the Imports (BoP, current US$) of Botswana and Imports (BoP, current US$) of Tonga?
Offer a very short reply. 5.09e+09. In the year 2009, what is the difference between the Imports (BoP, current US$) of Burundi and Imports (BoP, current US$) of Mexico?
Ensure brevity in your answer.  -2.59e+11. In the year 2009, what is the difference between the Imports (BoP, current US$) of Burundi and Imports (BoP, current US$) of Tonga?
Provide a succinct answer. 2.80e+08. In the year 2009, what is the difference between the Imports (BoP, current US$) of Mexico and Imports (BoP, current US$) of Tonga?
Provide a succinct answer. 2.60e+11. In the year 2010, what is the difference between the Imports (BoP, current US$) in Botswana and Imports (BoP, current US$) in Burundi?
Ensure brevity in your answer.  5.75e+09. In the year 2010, what is the difference between the Imports (BoP, current US$) of Botswana and Imports (BoP, current US$) of Mexico?
Provide a succinct answer. -3.21e+11. In the year 2010, what is the difference between the Imports (BoP, current US$) of Botswana and Imports (BoP, current US$) of Tonga?
Make the answer very short. 6.13e+09. In the year 2010, what is the difference between the Imports (BoP, current US$) in Burundi and Imports (BoP, current US$) in Mexico?
Your response must be concise. -3.27e+11. In the year 2010, what is the difference between the Imports (BoP, current US$) in Burundi and Imports (BoP, current US$) in Tonga?
Keep it short and to the point. 3.79e+08. In the year 2010, what is the difference between the Imports (BoP, current US$) in Mexico and Imports (BoP, current US$) in Tonga?
Offer a very short reply. 3.27e+11. In the year 2011, what is the difference between the Imports (BoP, current US$) of Botswana and Imports (BoP, current US$) of Burundi?
Your response must be concise. 7.27e+09. In the year 2011, what is the difference between the Imports (BoP, current US$) of Botswana and Imports (BoP, current US$) of Mexico?
Provide a short and direct response. -3.74e+11. In the year 2011, what is the difference between the Imports (BoP, current US$) in Botswana and Imports (BoP, current US$) in Tonga?
Provide a succinct answer. 7.75e+09. In the year 2011, what is the difference between the Imports (BoP, current US$) of Burundi and Imports (BoP, current US$) of Mexico?
Provide a succinct answer. -3.81e+11. In the year 2011, what is the difference between the Imports (BoP, current US$) in Burundi and Imports (BoP, current US$) in Tonga?
Offer a terse response. 4.88e+08. In the year 2011, what is the difference between the Imports (BoP, current US$) in Mexico and Imports (BoP, current US$) in Tonga?
Ensure brevity in your answer.  3.81e+11. In the year 2012, what is the difference between the Imports (BoP, current US$) of Botswana and Imports (BoP, current US$) of Burundi?
Your response must be concise. 7.67e+09. In the year 2012, what is the difference between the Imports (BoP, current US$) of Botswana and Imports (BoP, current US$) of Mexico?
Provide a short and direct response. -3.93e+11. In the year 2012, what is the difference between the Imports (BoP, current US$) of Botswana and Imports (BoP, current US$) of Tonga?
Provide a succinct answer. 8.32e+09. In the year 2012, what is the difference between the Imports (BoP, current US$) of Burundi and Imports (BoP, current US$) of Mexico?
Keep it short and to the point. -4.01e+11. In the year 2012, what is the difference between the Imports (BoP, current US$) in Burundi and Imports (BoP, current US$) in Tonga?
Your answer should be very brief. 6.52e+08. In the year 2012, what is the difference between the Imports (BoP, current US$) in Mexico and Imports (BoP, current US$) in Tonga?
Your answer should be compact. 4.02e+11. What is the ratio of the Imports (BoP, current US$) in Botswana in 2006 to that in 2007?
Your answer should be compact. 0.71. What is the ratio of the Imports (BoP, current US$) in Burundi in 2006 to that in 2007?
Offer a terse response. 1.02. What is the ratio of the Imports (BoP, current US$) of Mexico in 2006 to that in 2007?
Ensure brevity in your answer.  0.91. What is the ratio of the Imports (BoP, current US$) of Tonga in 2006 to that in 2007?
Ensure brevity in your answer.  0.85. What is the ratio of the Imports (BoP, current US$) in Burundi in 2006 to that in 2008?
Your answer should be compact. 0.75. What is the ratio of the Imports (BoP, current US$) of Mexico in 2006 to that in 2008?
Keep it short and to the point. 0.84. What is the ratio of the Imports (BoP, current US$) of Tonga in 2006 to that in 2008?
Make the answer very short. 0.69. What is the ratio of the Imports (BoP, current US$) of Botswana in 2006 to that in 2009?
Give a very brief answer. 0.63. What is the ratio of the Imports (BoP, current US$) of Burundi in 2006 to that in 2009?
Provide a succinct answer. 0.86. What is the ratio of the Imports (BoP, current US$) in Mexico in 2006 to that in 2009?
Your answer should be very brief. 1.08. What is the ratio of the Imports (BoP, current US$) of Tonga in 2006 to that in 2009?
Make the answer very short. 0.71. What is the ratio of the Imports (BoP, current US$) of Botswana in 2006 to that in 2010?
Provide a short and direct response. 0.53. What is the ratio of the Imports (BoP, current US$) of Burundi in 2006 to that in 2010?
Give a very brief answer. 0.74. What is the ratio of the Imports (BoP, current US$) of Mexico in 2006 to that in 2010?
Offer a very short reply. 0.86. What is the ratio of the Imports (BoP, current US$) of Tonga in 2006 to that in 2010?
Provide a short and direct response. 0.75. What is the ratio of the Imports (BoP, current US$) of Botswana in 2006 to that in 2011?
Provide a short and direct response. 0.42. What is the ratio of the Imports (BoP, current US$) in Burundi in 2006 to that in 2011?
Make the answer very short. 0.58. What is the ratio of the Imports (BoP, current US$) of Mexico in 2006 to that in 2011?
Offer a very short reply. 0.73. What is the ratio of the Imports (BoP, current US$) of Tonga in 2006 to that in 2011?
Offer a terse response. 0.61. What is the ratio of the Imports (BoP, current US$) of Botswana in 2006 to that in 2012?
Keep it short and to the point. 0.39. What is the ratio of the Imports (BoP, current US$) in Burundi in 2006 to that in 2012?
Your response must be concise. 0.48. What is the ratio of the Imports (BoP, current US$) of Mexico in 2006 to that in 2012?
Offer a very short reply. 0.7. What is the ratio of the Imports (BoP, current US$) in Tonga in 2006 to that in 2012?
Give a very brief answer. 0.63. What is the ratio of the Imports (BoP, current US$) of Botswana in 2007 to that in 2008?
Make the answer very short. 0.85. What is the ratio of the Imports (BoP, current US$) in Burundi in 2007 to that in 2008?
Your answer should be very brief. 0.73. What is the ratio of the Imports (BoP, current US$) in Mexico in 2007 to that in 2008?
Your response must be concise. 0.92. What is the ratio of the Imports (BoP, current US$) of Tonga in 2007 to that in 2008?
Give a very brief answer. 0.81. What is the ratio of the Imports (BoP, current US$) in Botswana in 2007 to that in 2009?
Offer a terse response. 0.89. What is the ratio of the Imports (BoP, current US$) in Burundi in 2007 to that in 2009?
Offer a very short reply. 0.84. What is the ratio of the Imports (BoP, current US$) of Mexico in 2007 to that in 2009?
Your answer should be compact. 1.18. What is the ratio of the Imports (BoP, current US$) in Botswana in 2007 to that in 2010?
Your answer should be very brief. 0.74. What is the ratio of the Imports (BoP, current US$) of Burundi in 2007 to that in 2010?
Offer a terse response. 0.72. What is the ratio of the Imports (BoP, current US$) of Mexico in 2007 to that in 2010?
Your answer should be compact. 0.94. What is the ratio of the Imports (BoP, current US$) of Tonga in 2007 to that in 2010?
Ensure brevity in your answer.  0.88. What is the ratio of the Imports (BoP, current US$) in Botswana in 2007 to that in 2011?
Ensure brevity in your answer.  0.59. What is the ratio of the Imports (BoP, current US$) in Burundi in 2007 to that in 2011?
Ensure brevity in your answer.  0.57. What is the ratio of the Imports (BoP, current US$) of Mexico in 2007 to that in 2011?
Your answer should be compact. 0.81. What is the ratio of the Imports (BoP, current US$) in Tonga in 2007 to that in 2011?
Keep it short and to the point. 0.72. What is the ratio of the Imports (BoP, current US$) in Botswana in 2007 to that in 2012?
Provide a short and direct response. 0.55. What is the ratio of the Imports (BoP, current US$) in Burundi in 2007 to that in 2012?
Keep it short and to the point. 0.47. What is the ratio of the Imports (BoP, current US$) in Mexico in 2007 to that in 2012?
Make the answer very short. 0.77. What is the ratio of the Imports (BoP, current US$) in Tonga in 2007 to that in 2012?
Give a very brief answer. 0.74. What is the ratio of the Imports (BoP, current US$) of Botswana in 2008 to that in 2009?
Your answer should be very brief. 1.05. What is the ratio of the Imports (BoP, current US$) in Burundi in 2008 to that in 2009?
Provide a succinct answer. 1.14. What is the ratio of the Imports (BoP, current US$) of Mexico in 2008 to that in 2009?
Your response must be concise. 1.29. What is the ratio of the Imports (BoP, current US$) in Tonga in 2008 to that in 2009?
Make the answer very short. 1.03. What is the ratio of the Imports (BoP, current US$) in Botswana in 2008 to that in 2010?
Offer a very short reply. 0.88. What is the ratio of the Imports (BoP, current US$) of Burundi in 2008 to that in 2010?
Give a very brief answer. 0.98. What is the ratio of the Imports (BoP, current US$) in Mexico in 2008 to that in 2010?
Give a very brief answer. 1.02. What is the ratio of the Imports (BoP, current US$) of Tonga in 2008 to that in 2010?
Your response must be concise. 1.09. What is the ratio of the Imports (BoP, current US$) in Botswana in 2008 to that in 2011?
Give a very brief answer. 0.7. What is the ratio of the Imports (BoP, current US$) in Burundi in 2008 to that in 2011?
Offer a terse response. 0.78. What is the ratio of the Imports (BoP, current US$) in Mexico in 2008 to that in 2011?
Your response must be concise. 0.88. What is the ratio of the Imports (BoP, current US$) of Tonga in 2008 to that in 2011?
Ensure brevity in your answer.  0.89. What is the ratio of the Imports (BoP, current US$) of Botswana in 2008 to that in 2012?
Your response must be concise. 0.65. What is the ratio of the Imports (BoP, current US$) of Burundi in 2008 to that in 2012?
Your answer should be very brief. 0.64. What is the ratio of the Imports (BoP, current US$) of Mexico in 2008 to that in 2012?
Offer a very short reply. 0.83. What is the ratio of the Imports (BoP, current US$) in Tonga in 2008 to that in 2012?
Offer a terse response. 0.91. What is the ratio of the Imports (BoP, current US$) of Botswana in 2009 to that in 2010?
Your answer should be very brief. 0.84. What is the ratio of the Imports (BoP, current US$) in Burundi in 2009 to that in 2010?
Provide a succinct answer. 0.86. What is the ratio of the Imports (BoP, current US$) of Mexico in 2009 to that in 2010?
Your response must be concise. 0.79. What is the ratio of the Imports (BoP, current US$) of Tonga in 2009 to that in 2010?
Make the answer very short. 1.05. What is the ratio of the Imports (BoP, current US$) of Botswana in 2009 to that in 2011?
Offer a very short reply. 0.66. What is the ratio of the Imports (BoP, current US$) of Burundi in 2009 to that in 2011?
Ensure brevity in your answer.  0.68. What is the ratio of the Imports (BoP, current US$) of Mexico in 2009 to that in 2011?
Provide a short and direct response. 0.68. What is the ratio of the Imports (BoP, current US$) of Tonga in 2009 to that in 2011?
Your answer should be compact. 0.86. What is the ratio of the Imports (BoP, current US$) in Botswana in 2009 to that in 2012?
Your answer should be compact. 0.62. What is the ratio of the Imports (BoP, current US$) of Burundi in 2009 to that in 2012?
Make the answer very short. 0.56. What is the ratio of the Imports (BoP, current US$) in Mexico in 2009 to that in 2012?
Offer a terse response. 0.65. What is the ratio of the Imports (BoP, current US$) in Tonga in 2009 to that in 2012?
Make the answer very short. 0.88. What is the ratio of the Imports (BoP, current US$) of Botswana in 2010 to that in 2011?
Your answer should be compact. 0.79. What is the ratio of the Imports (BoP, current US$) of Burundi in 2010 to that in 2011?
Your answer should be very brief. 0.79. What is the ratio of the Imports (BoP, current US$) of Mexico in 2010 to that in 2011?
Provide a succinct answer. 0.86. What is the ratio of the Imports (BoP, current US$) in Tonga in 2010 to that in 2011?
Your answer should be compact. 0.82. What is the ratio of the Imports (BoP, current US$) of Botswana in 2010 to that in 2012?
Ensure brevity in your answer.  0.74. What is the ratio of the Imports (BoP, current US$) in Burundi in 2010 to that in 2012?
Provide a succinct answer. 0.66. What is the ratio of the Imports (BoP, current US$) of Mexico in 2010 to that in 2012?
Offer a very short reply. 0.82. What is the ratio of the Imports (BoP, current US$) in Tonga in 2010 to that in 2012?
Give a very brief answer. 0.84. What is the ratio of the Imports (BoP, current US$) of Botswana in 2011 to that in 2012?
Provide a short and direct response. 0.94. What is the ratio of the Imports (BoP, current US$) in Burundi in 2011 to that in 2012?
Keep it short and to the point. 0.83. What is the ratio of the Imports (BoP, current US$) in Mexico in 2011 to that in 2012?
Keep it short and to the point. 0.95. What is the ratio of the Imports (BoP, current US$) in Tonga in 2011 to that in 2012?
Offer a terse response. 1.03. What is the difference between the highest and the second highest Imports (BoP, current US$) in Botswana?
Offer a very short reply. 5.57e+08. What is the difference between the highest and the second highest Imports (BoP, current US$) in Burundi?
Provide a succinct answer. 1.57e+08. What is the difference between the highest and the second highest Imports (BoP, current US$) in Mexico?
Keep it short and to the point. 2.03e+1. What is the difference between the highest and the second highest Imports (BoP, current US$) of Tonga?
Your response must be concise. 7.00e+06. What is the difference between the highest and the lowest Imports (BoP, current US$) in Botswana?
Ensure brevity in your answer.  5.24e+09. What is the difference between the highest and the lowest Imports (BoP, current US$) in Burundi?
Make the answer very short. 4.86e+08. What is the difference between the highest and the lowest Imports (BoP, current US$) of Mexico?
Your response must be concise. 1.42e+11. What is the difference between the highest and the lowest Imports (BoP, current US$) in Tonga?
Ensure brevity in your answer.  1.07e+08. 